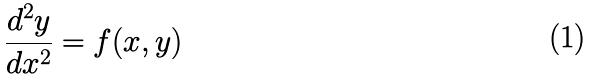Convert formula to latex. <formula><loc_0><loc_0><loc_500><loc_500>\frac { d ^ { 2 } y } { d x ^ { 2 } } = f ( x , y )</formula> 